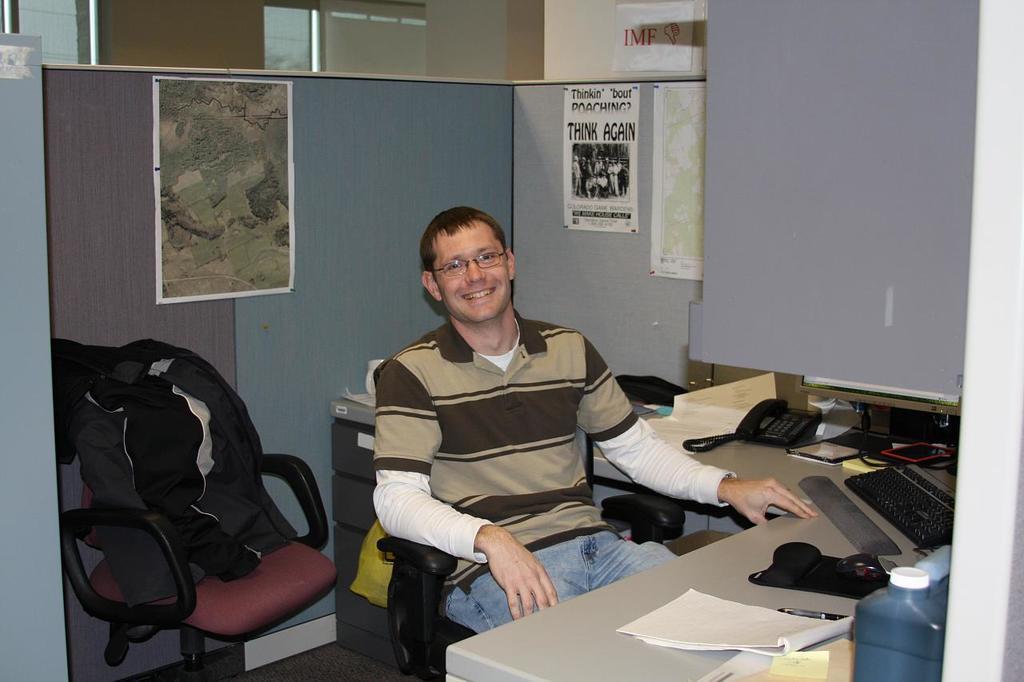Can you describe this image briefly? In this image a person is sitting on a chair. In front of him on a table there are papers, pen, phone, keyboard, bottle and drawers. The person is smiling. There is another chair on it there are cloth. In the background on the wall there are pictures. 